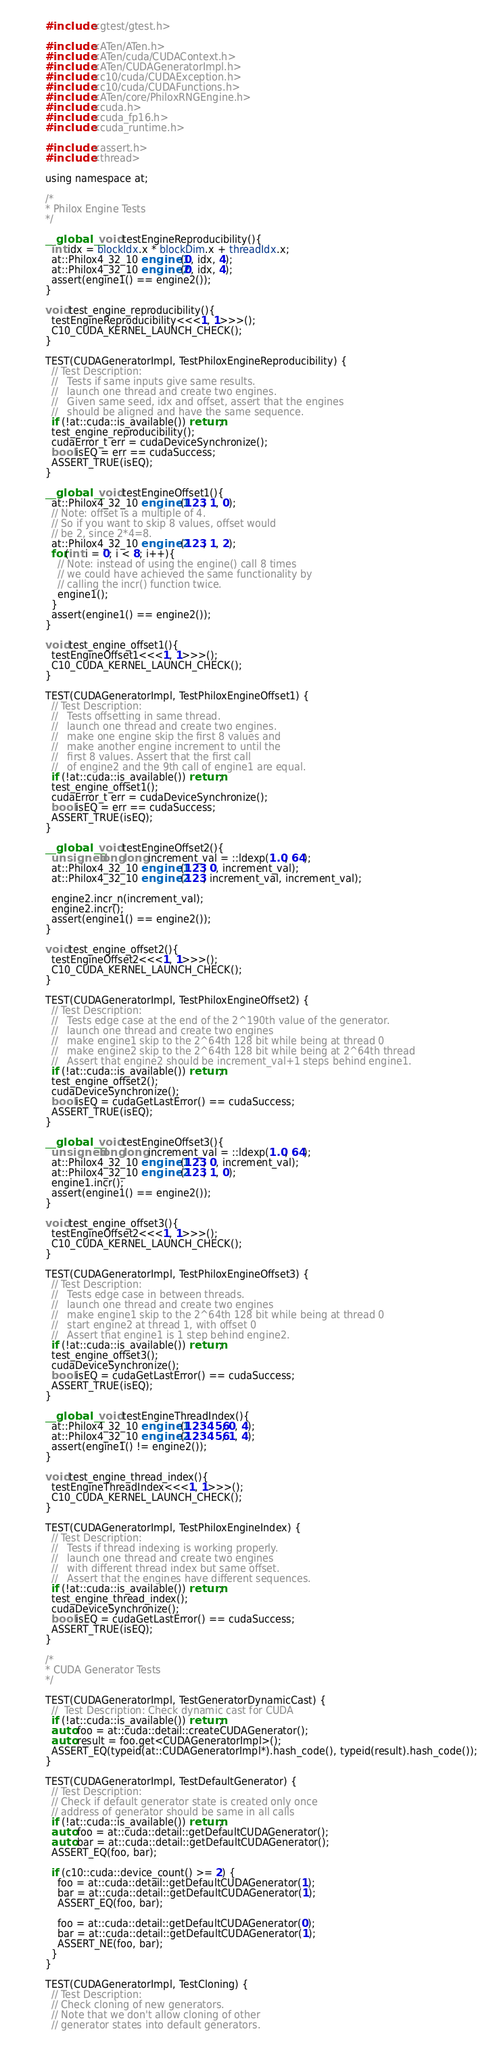<code> <loc_0><loc_0><loc_500><loc_500><_Cuda_>#include <gtest/gtest.h>

#include <ATen/ATen.h>
#include <ATen/cuda/CUDAContext.h>
#include <ATen/CUDAGeneratorImpl.h>
#include <c10/cuda/CUDAException.h>
#include <c10/cuda/CUDAFunctions.h>
#include <ATen/core/PhiloxRNGEngine.h>
#include <cuda.h>
#include <cuda_fp16.h>
#include <cuda_runtime.h>

#include <assert.h>
#include <thread>

using namespace at;

/*
* Philox Engine Tests
*/

__global__ void testEngineReproducibility(){
  int idx = blockIdx.x * blockDim.x + threadIdx.x;
  at::Philox4_32_10 engine1(0, idx, 4);
  at::Philox4_32_10 engine2(0, idx, 4);
  assert(engine1() == engine2());
}

void test_engine_reproducibility(){
  testEngineReproducibility<<<1, 1>>>();
  C10_CUDA_KERNEL_LAUNCH_CHECK();
}

TEST(CUDAGeneratorImpl, TestPhiloxEngineReproducibility) {
  // Test Description:
  //   Tests if same inputs give same results.
  //   launch one thread and create two engines.
  //   Given same seed, idx and offset, assert that the engines
  //   should be aligned and have the same sequence.
  if (!at::cuda::is_available()) return;
  test_engine_reproducibility();
  cudaError_t err = cudaDeviceSynchronize();
  bool isEQ = err == cudaSuccess;
  ASSERT_TRUE(isEQ);
}

__global__ void testEngineOffset1(){
  at::Philox4_32_10 engine1(123, 1, 0);
  // Note: offset is a multiple of 4.
  // So if you want to skip 8 values, offset would
  // be 2, since 2*4=8.
  at::Philox4_32_10 engine2(123, 1, 2);
  for(int i = 0; i < 8; i++){
    // Note: instead of using the engine() call 8 times
    // we could have achieved the same functionality by
    // calling the incr() function twice.
    engine1();
  }
  assert(engine1() == engine2());
}

void test_engine_offset1(){
  testEngineOffset1<<<1, 1>>>();
  C10_CUDA_KERNEL_LAUNCH_CHECK();
}

TEST(CUDAGeneratorImpl, TestPhiloxEngineOffset1) {
  // Test Description:
  //   Tests offsetting in same thread.
  //   launch one thread and create two engines.
  //   make one engine skip the first 8 values and
  //   make another engine increment to until the
  //   first 8 values. Assert that the first call
  //   of engine2 and the 9th call of engine1 are equal.
  if (!at::cuda::is_available()) return;
  test_engine_offset1();
  cudaError_t err = cudaDeviceSynchronize();
  bool isEQ = err == cudaSuccess;
  ASSERT_TRUE(isEQ);
}

__global__ void testEngineOffset2(){
  unsigned long long increment_val = ::ldexp(1.0, 64);
  at::Philox4_32_10 engine1(123, 0, increment_val);
  at::Philox4_32_10 engine2(123, increment_val, increment_val);

  engine2.incr_n(increment_val);
  engine2.incr();
  assert(engine1() == engine2());
}

void test_engine_offset2(){
  testEngineOffset2<<<1, 1>>>();
  C10_CUDA_KERNEL_LAUNCH_CHECK();
}

TEST(CUDAGeneratorImpl, TestPhiloxEngineOffset2) {
  // Test Description:
  //   Tests edge case at the end of the 2^190th value of the generator.
  //   launch one thread and create two engines
  //   make engine1 skip to the 2^64th 128 bit while being at thread 0
  //   make engine2 skip to the 2^64th 128 bit while being at 2^64th thread
  //   Assert that engine2 should be increment_val+1 steps behind engine1.
  if (!at::cuda::is_available()) return;
  test_engine_offset2();
  cudaDeviceSynchronize();
  bool isEQ = cudaGetLastError() == cudaSuccess;
  ASSERT_TRUE(isEQ);
}

__global__ void testEngineOffset3(){
  unsigned long long increment_val = ::ldexp(1.0, 64);
  at::Philox4_32_10 engine1(123, 0, increment_val);
  at::Philox4_32_10 engine2(123, 1, 0);
  engine1.incr();
  assert(engine1() == engine2());
}

void test_engine_offset3(){
  testEngineOffset2<<<1, 1>>>();
  C10_CUDA_KERNEL_LAUNCH_CHECK();
}

TEST(CUDAGeneratorImpl, TestPhiloxEngineOffset3) {
  // Test Description:
  //   Tests edge case in between threads.
  //   launch one thread and create two engines
  //   make engine1 skip to the 2^64th 128 bit while being at thread 0
  //   start engine2 at thread 1, with offset 0
  //   Assert that engine1 is 1 step behind engine2.
  if (!at::cuda::is_available()) return;
  test_engine_offset3();
  cudaDeviceSynchronize();
  bool isEQ = cudaGetLastError() == cudaSuccess;
  ASSERT_TRUE(isEQ);
}

__global__ void testEngineThreadIndex(){
  at::Philox4_32_10 engine1(123456, 0, 4);
  at::Philox4_32_10 engine2(123456, 1, 4);
  assert(engine1() != engine2());
}

void test_engine_thread_index(){
  testEngineThreadIndex<<<1, 1>>>();
  C10_CUDA_KERNEL_LAUNCH_CHECK();
}

TEST(CUDAGeneratorImpl, TestPhiloxEngineIndex) {
  // Test Description:
  //   Tests if thread indexing is working properly.
  //   launch one thread and create two engines
  //   with different thread index but same offset.
  //   Assert that the engines have different sequences.
  if (!at::cuda::is_available()) return;
  test_engine_thread_index();
  cudaDeviceSynchronize();
  bool isEQ = cudaGetLastError() == cudaSuccess;
  ASSERT_TRUE(isEQ);
}

/*
* CUDA Generator Tests
*/

TEST(CUDAGeneratorImpl, TestGeneratorDynamicCast) {
  //  Test Description: Check dynamic cast for CUDA
  if (!at::cuda::is_available()) return;
  auto foo = at::cuda::detail::createCUDAGenerator();
  auto result = foo.get<CUDAGeneratorImpl>();
  ASSERT_EQ(typeid(at::CUDAGeneratorImpl*).hash_code(), typeid(result).hash_code());
}

TEST(CUDAGeneratorImpl, TestDefaultGenerator) {
  // Test Description:
  // Check if default generator state is created only once
  // address of generator should be same in all calls
  if (!at::cuda::is_available()) return;
  auto foo = at::cuda::detail::getDefaultCUDAGenerator();
  auto bar = at::cuda::detail::getDefaultCUDAGenerator();
  ASSERT_EQ(foo, bar);

  if (c10::cuda::device_count() >= 2) {
    foo = at::cuda::detail::getDefaultCUDAGenerator(1);
    bar = at::cuda::detail::getDefaultCUDAGenerator(1);
    ASSERT_EQ(foo, bar);

    foo = at::cuda::detail::getDefaultCUDAGenerator(0);
    bar = at::cuda::detail::getDefaultCUDAGenerator(1);
    ASSERT_NE(foo, bar);
  }
}

TEST(CUDAGeneratorImpl, TestCloning) {
  // Test Description:
  // Check cloning of new generators.
  // Note that we don't allow cloning of other
  // generator states into default generators.</code> 